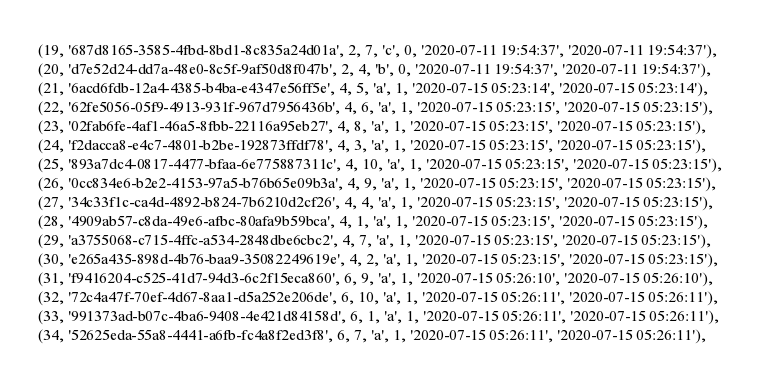<code> <loc_0><loc_0><loc_500><loc_500><_SQL_>(19, '687d8165-3585-4fbd-8bd1-8c835a24d01a', 2, 7, 'c', 0, '2020-07-11 19:54:37', '2020-07-11 19:54:37'),
(20, 'd7e52d24-dd7a-48e0-8c5f-9af50d8f047b', 2, 4, 'b', 0, '2020-07-11 19:54:37', '2020-07-11 19:54:37'),
(21, '6acd6fdb-12a4-4385-b4ba-e4347e56ff5e', 4, 5, 'a', 1, '2020-07-15 05:23:14', '2020-07-15 05:23:14'),
(22, '62fe5056-05f9-4913-931f-967d7956436b', 4, 6, 'a', 1, '2020-07-15 05:23:15', '2020-07-15 05:23:15'),
(23, '02fab6fe-4af1-46a5-8fbb-22116a95eb27', 4, 8, 'a', 1, '2020-07-15 05:23:15', '2020-07-15 05:23:15'),
(24, 'f2dacca8-e4c7-4801-b2be-192873ffdf78', 4, 3, 'a', 1, '2020-07-15 05:23:15', '2020-07-15 05:23:15'),
(25, '893a7dc4-0817-4477-bfaa-6e775887311c', 4, 10, 'a', 1, '2020-07-15 05:23:15', '2020-07-15 05:23:15'),
(26, '0cc834e6-b2e2-4153-97a5-b76b65e09b3a', 4, 9, 'a', 1, '2020-07-15 05:23:15', '2020-07-15 05:23:15'),
(27, '34c33f1c-ca4d-4892-b824-7b6210d2cf26', 4, 4, 'a', 1, '2020-07-15 05:23:15', '2020-07-15 05:23:15'),
(28, '4909ab57-c8da-49e6-afbc-80afa9b59bca', 4, 1, 'a', 1, '2020-07-15 05:23:15', '2020-07-15 05:23:15'),
(29, 'a3755068-c715-4ffc-a534-2848dbe6cbc2', 4, 7, 'a', 1, '2020-07-15 05:23:15', '2020-07-15 05:23:15'),
(30, 'e265a435-898d-4b76-baa9-35082249619e', 4, 2, 'a', 1, '2020-07-15 05:23:15', '2020-07-15 05:23:15'),
(31, 'f9416204-c525-41d7-94d3-6c2f15eca860', 6, 9, 'a', 1, '2020-07-15 05:26:10', '2020-07-15 05:26:10'),
(32, '72c4a47f-70ef-4d67-8aa1-d5a252e206de', 6, 10, 'a', 1, '2020-07-15 05:26:11', '2020-07-15 05:26:11'),
(33, '991373ad-b07c-4ba6-9408-4e421d84158d', 6, 1, 'a', 1, '2020-07-15 05:26:11', '2020-07-15 05:26:11'),
(34, '52625eda-55a8-4441-a6fb-fc4a8f2ed3f8', 6, 7, 'a', 1, '2020-07-15 05:26:11', '2020-07-15 05:26:11'),</code> 